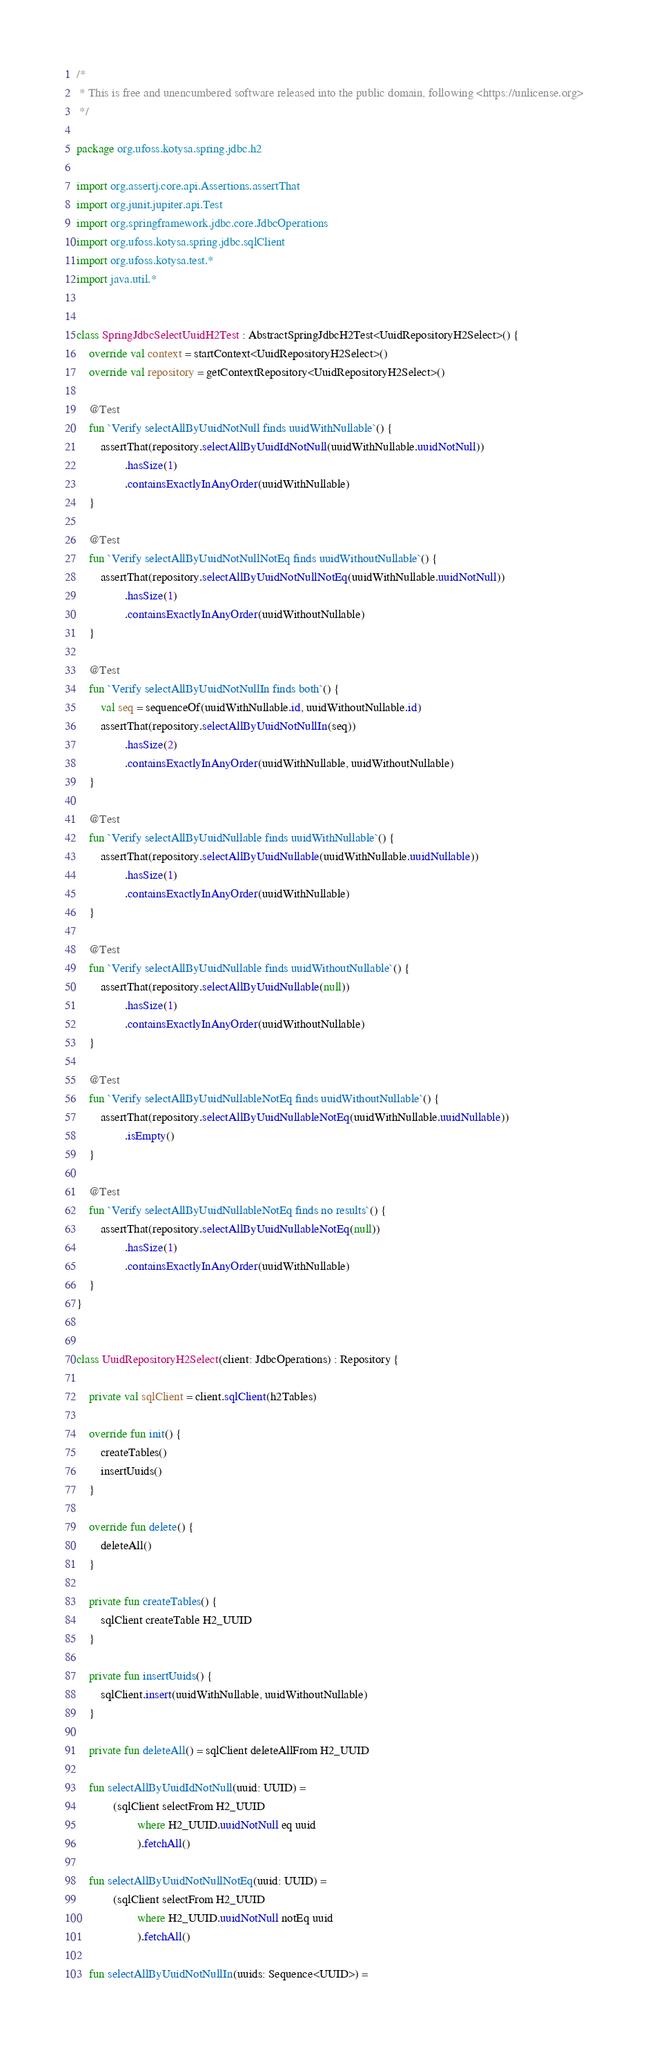<code> <loc_0><loc_0><loc_500><loc_500><_Kotlin_>/*
 * This is free and unencumbered software released into the public domain, following <https://unlicense.org>
 */

package org.ufoss.kotysa.spring.jdbc.h2

import org.assertj.core.api.Assertions.assertThat
import org.junit.jupiter.api.Test
import org.springframework.jdbc.core.JdbcOperations
import org.ufoss.kotysa.spring.jdbc.sqlClient
import org.ufoss.kotysa.test.*
import java.util.*


class SpringJdbcSelectUuidH2Test : AbstractSpringJdbcH2Test<UuidRepositoryH2Select>() {
    override val context = startContext<UuidRepositoryH2Select>()
    override val repository = getContextRepository<UuidRepositoryH2Select>()

    @Test
    fun `Verify selectAllByUuidNotNull finds uuidWithNullable`() {
        assertThat(repository.selectAllByUuidIdNotNull(uuidWithNullable.uuidNotNull))
                .hasSize(1)
                .containsExactlyInAnyOrder(uuidWithNullable)
    }

    @Test
    fun `Verify selectAllByUuidNotNullNotEq finds uuidWithoutNullable`() {
        assertThat(repository.selectAllByUuidNotNullNotEq(uuidWithNullable.uuidNotNull))
                .hasSize(1)
                .containsExactlyInAnyOrder(uuidWithoutNullable)
    }

    @Test
    fun `Verify selectAllByUuidNotNullIn finds both`() {
        val seq = sequenceOf(uuidWithNullable.id, uuidWithoutNullable.id)
        assertThat(repository.selectAllByUuidNotNullIn(seq))
                .hasSize(2)
                .containsExactlyInAnyOrder(uuidWithNullable, uuidWithoutNullable)
    }

    @Test
    fun `Verify selectAllByUuidNullable finds uuidWithNullable`() {
        assertThat(repository.selectAllByUuidNullable(uuidWithNullable.uuidNullable))
                .hasSize(1)
                .containsExactlyInAnyOrder(uuidWithNullable)
    }

    @Test
    fun `Verify selectAllByUuidNullable finds uuidWithoutNullable`() {
        assertThat(repository.selectAllByUuidNullable(null))
                .hasSize(1)
                .containsExactlyInAnyOrder(uuidWithoutNullable)
    }

    @Test
    fun `Verify selectAllByUuidNullableNotEq finds uuidWithoutNullable`() {
        assertThat(repository.selectAllByUuidNullableNotEq(uuidWithNullable.uuidNullable))
                .isEmpty()
    }

    @Test
    fun `Verify selectAllByUuidNullableNotEq finds no results`() {
        assertThat(repository.selectAllByUuidNullableNotEq(null))
                .hasSize(1)
                .containsExactlyInAnyOrder(uuidWithNullable)
    }
}


class UuidRepositoryH2Select(client: JdbcOperations) : Repository {

    private val sqlClient = client.sqlClient(h2Tables)

    override fun init() {
        createTables()
        insertUuids()
    }

    override fun delete() {
        deleteAll()
    }

    private fun createTables() {
        sqlClient createTable H2_UUID
    }

    private fun insertUuids() {
        sqlClient.insert(uuidWithNullable, uuidWithoutNullable)
    }

    private fun deleteAll() = sqlClient deleteAllFrom H2_UUID

    fun selectAllByUuidIdNotNull(uuid: UUID) =
            (sqlClient selectFrom H2_UUID
                    where H2_UUID.uuidNotNull eq uuid
                    ).fetchAll()

    fun selectAllByUuidNotNullNotEq(uuid: UUID) =
            (sqlClient selectFrom H2_UUID
                    where H2_UUID.uuidNotNull notEq uuid
                    ).fetchAll()

    fun selectAllByUuidNotNullIn(uuids: Sequence<UUID>) =</code> 